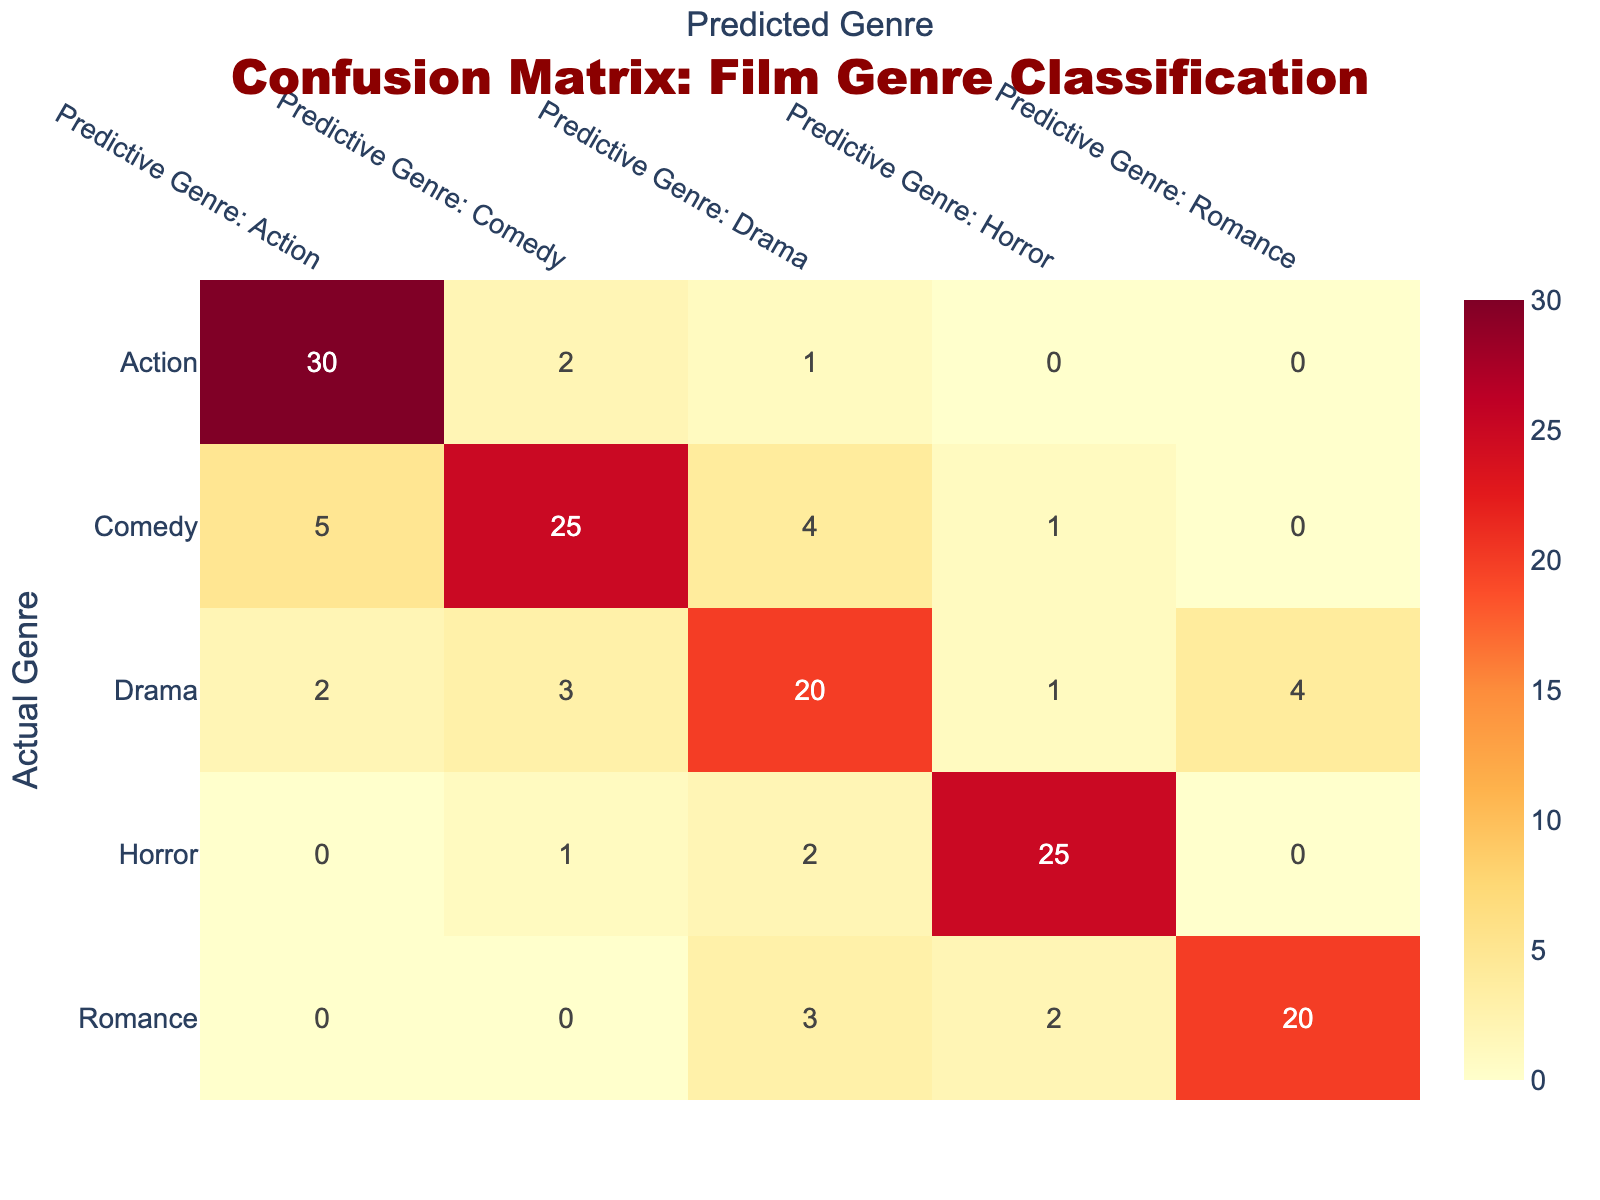What is the number of films correctly predicted as Action? From the confusion matrix, the value in the cell where Actual Genre is Action and Predictive Genre is Action corresponds to the correct predictions. This value is 30.
Answer: 30 How many films were predicted as Comedy? To find this, we look at the column for Predictive Genre: Comedy. The total predictions for this genre are calculated by summing the values in that column: 2 (Action) + 25 (Comedy) + 3 (Drama) + 1 (Horror) + 0 (Romance) = 31.
Answer: 31 What genre had the highest number of misclassifications? We analyze the misclassifications by looking at the off-diagonal entries in each genre's row. For Horror, the values are 0 (Action), 1 (Comedy), 2 (Drama), and 0 (Romance), giving a total of 3 misclassifications. For Drama, we have 2 (Action), 3 (Comedy), 1 (Horror), and 4 (Romance), summing to 10. For Comedy, the misclassifications total 10 as well. By checking all rows, Drama and Comedy have the highest misclassification numbers of 10.
Answer: Drama and Comedy What is the total number of films watched by students? To find the total, we sum all values in the confusion matrix, including both correct and incorrect predictions: 30 + 2 + 1 + 0 + 0 + 5 + 25 + 4 + 1 + 0 + 2 + 3 + 20 + 1 + 4 + 0 + 1 + 2 + 25 + 0 + 0 + 0 + 3 + 2 + 20 = 100.
Answer: 100 Is it true that more films were incorrectly classified as Horror than Romance? To answer this, we look at the total number of misclassifications for each genre. For Horror, the misclassifications are 1 (Comedy) + 2 (Drama) + 0 (Romance) = 3. For Romance, the values are 0 (Action) + 0 (Comedy) + 3 (Drama) + 2 (Horror) = 5. Since 3 < 5, it is false that more films were incorrectly classified as Horror than Romance.
Answer: No How many films had the actual genre Drama but were incorrectly predicted as Action? From the confusion matrix, the value where Actual Genre is Drama and Predictive Genre is Action corresponds to the incorrect predictions and is 2.
Answer: 2 What is the average number of misclassifications for the Action genre across all predictive genres? The off-diagonal entries in the Action row are 2 (Comedy) + 1 (Drama) + 0 (Horror) + 0 (Romance), totaling 3 misclassifications. The average is thus 3 misclassifications / 4 predictive genres = 0.75.
Answer: 0.75 Which genre had the least number of films watched based on the actual observed values? We will total the actual values for each genre: Action (30), Comedy (25), Drama (30), Horror (25), and Romance (25). The genre with the least number is Comedy, with 25 films.
Answer: Comedy 